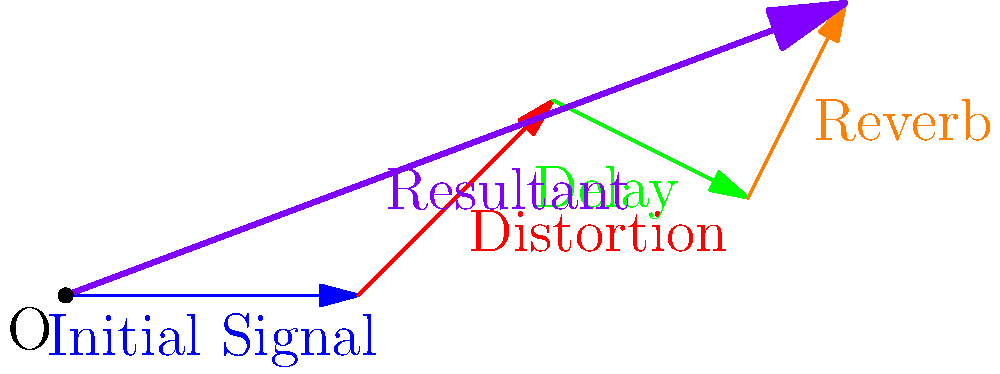As a guitarist who values stability in your sound, you're considering adding multiple effects pedals to your signal chain. The diagram shows the vector representation of how each pedal affects your guitar's signal. If you combine a distortion pedal (red vector), a delay pedal (green vector), and a reverb pedal (orange vector) in that order, what is the magnitude of the resultant vector (purple) rounded to the nearest whole number? To find the magnitude of the resultant vector, we need to follow these steps:

1. Identify the coordinates of the final point of the resultant vector:
   The resultant vector starts at (0,0) and ends at (8,3).

2. Calculate the horizontal and vertical components of the resultant vector:
   Horizontal component: $x = 8 - 0 = 8$
   Vertical component: $y = 3 - 0 = 3$

3. Use the Pythagorean theorem to calculate the magnitude of the resultant vector:
   $\text{Magnitude} = \sqrt{x^2 + y^2}$
   $\text{Magnitude} = \sqrt{8^2 + 3^2}$
   $\text{Magnitude} = \sqrt{64 + 9}$
   $\text{Magnitude} = \sqrt{73}$

4. Calculate the square root of 73:
   $\sqrt{73} \approx 8.544$

5. Round to the nearest whole number:
   8.544 rounds to 9

Therefore, the magnitude of the resultant vector, rounded to the nearest whole number, is 9.
Answer: 9 